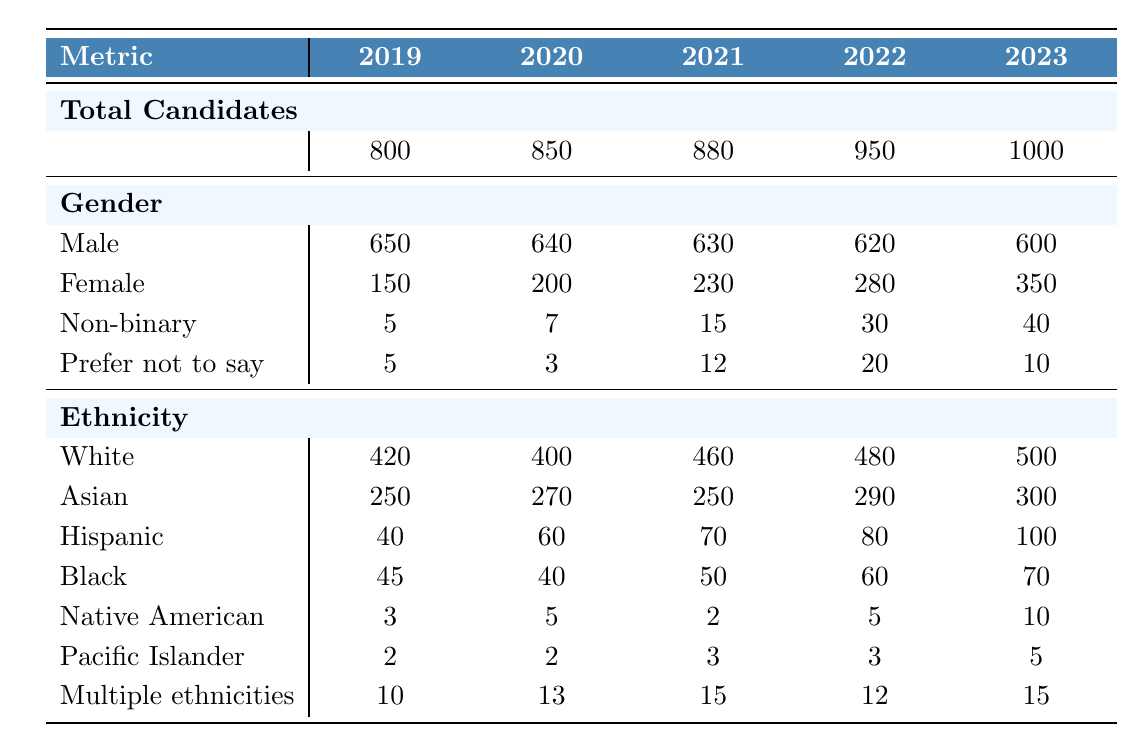What was the total number of candidates in 2023? The table states that the total number of candidates for the year 2023 is listed directly under the "Total Candidates" row, which shows the value of 1000.
Answer: 1000 How many female candidates were there in 2021? From the table, the number of female candidates in the year 2021 is listed under the "Gender" section, specifically for "Female," which shows the value of 230.
Answer: 230 What is the percentage of male candidates in 2020? In 2020, there were 640 male candidates out of a total of 850 candidates. To calculate the percentage: (640/850) * 100 = 75.29%.
Answer: 75.29% Which year had the highest number of Hispanic candidates? By inspecting the "Hispanic" row in the "Ethnicity" section, the values are 40 (2019), 60 (2020), 70 (2021), 80 (2022), and 100 (2023). The year with the highest count is 2023 with 100 Hispanic candidates.
Answer: 2023 Was there an increase in the number of non-binary candidates from 2019 to 2023? The table shows that in 2019 there were 5 non-binary candidates and in 2023 there were 40. Since 40 is greater than 5, there was indeed an increase.
Answer: Yes What was the total number of candidates from 2020 to 2022? To find this total, sum the candidates for each year: 850 (2020) + 950 (2021) + 1000 (2022) = 2800.
Answer: 2800 Which gender category saw the largest increase in candidates from 2022 to 2023? Looking at the gender data, Female candidates increased from 280 (2022) to 350 (2023), which is an increase of 70. All other categories either decreased or had smaller increases.
Answer: Female How does the representation of Black candidates in 2020 compare to 2023? In 2020, there were 40 Black candidates, and in 2023, there were 70 Black candidates. Comparing these values shows an increase of 30 Black candidates from 2020 to 2023.
Answer: Increased by 30 What is the total number of candidates that preferred not to say their gender across all years? The values for "Prefer not to say" are 5 (2019), 3 (2020), 12 (2021), 20 (2022), and 10 (2023). Summing these gives: 5 + 3 + 12 + 20 + 10 = 50.
Answer: 50 Is the total number of Asian candidates in 2022 higher than that in 2020? The number of Asian candidates in 2022 was 290, while in 2020 it was 270. Since 290 is greater than 270, 2022 indeed had more Asian candidates than 2020.
Answer: Yes 